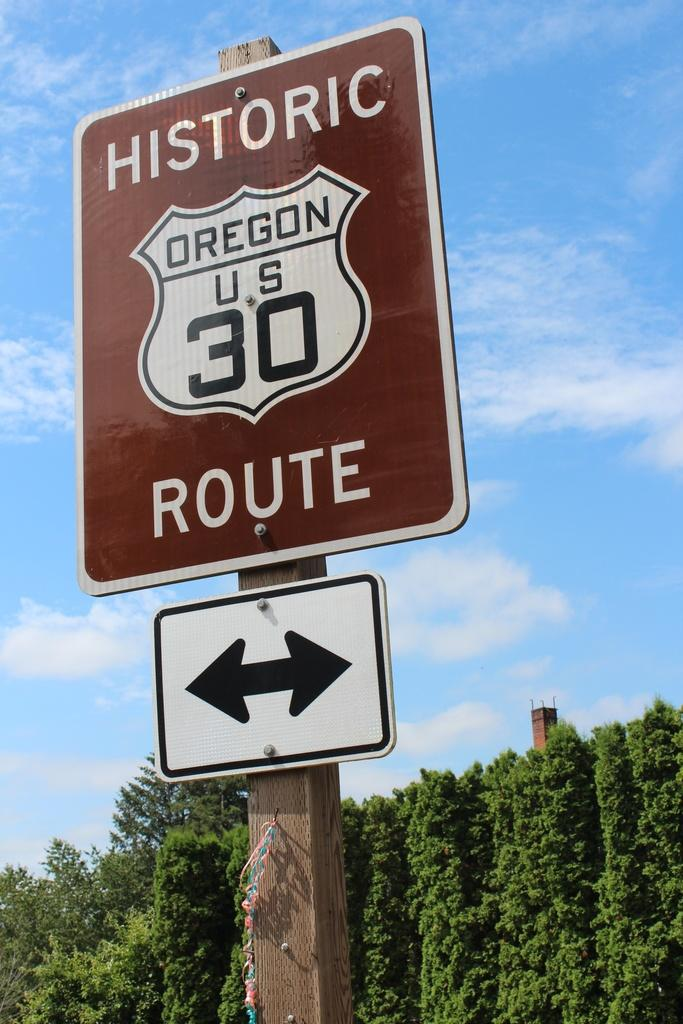<image>
Give a short and clear explanation of the subsequent image. A sign for Oregen US 30 labeled Historic Route. 